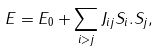Convert formula to latex. <formula><loc_0><loc_0><loc_500><loc_500>E = E _ { 0 } + \sum _ { i > j } J _ { i j } { S _ { i } } . { S _ { j } } ,</formula> 